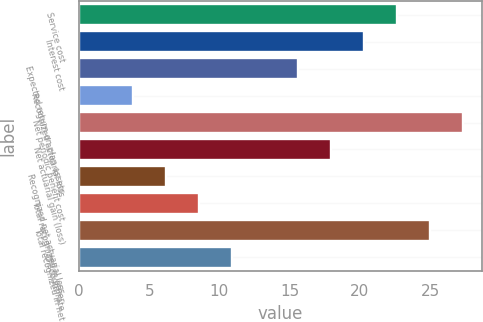<chart> <loc_0><loc_0><loc_500><loc_500><bar_chart><fcel>Service cost<fcel>Interest cost<fcel>Expected return on plan assets<fcel>Recognized actuarial loss<fcel>Net periodic benefit cost<fcel>Net actuarial gain (loss)<fcel>Recognized net actuarial loss<fcel>Total recognized in other<fcel>Total recognized in net<fcel>Discount rate<nl><fcel>22.65<fcel>20.3<fcel>15.6<fcel>3.85<fcel>27.35<fcel>17.95<fcel>6.2<fcel>8.55<fcel>25<fcel>10.9<nl></chart> 